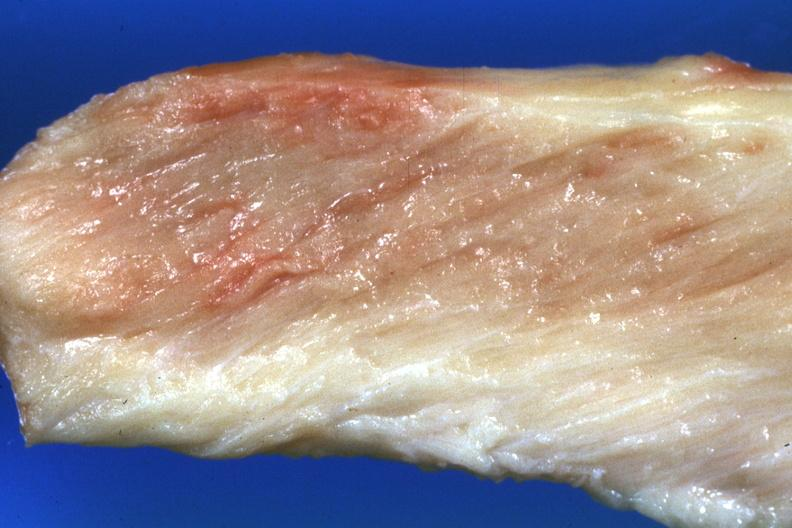how is close-up view muscle?
Answer the question using a single word or phrase. Pale 